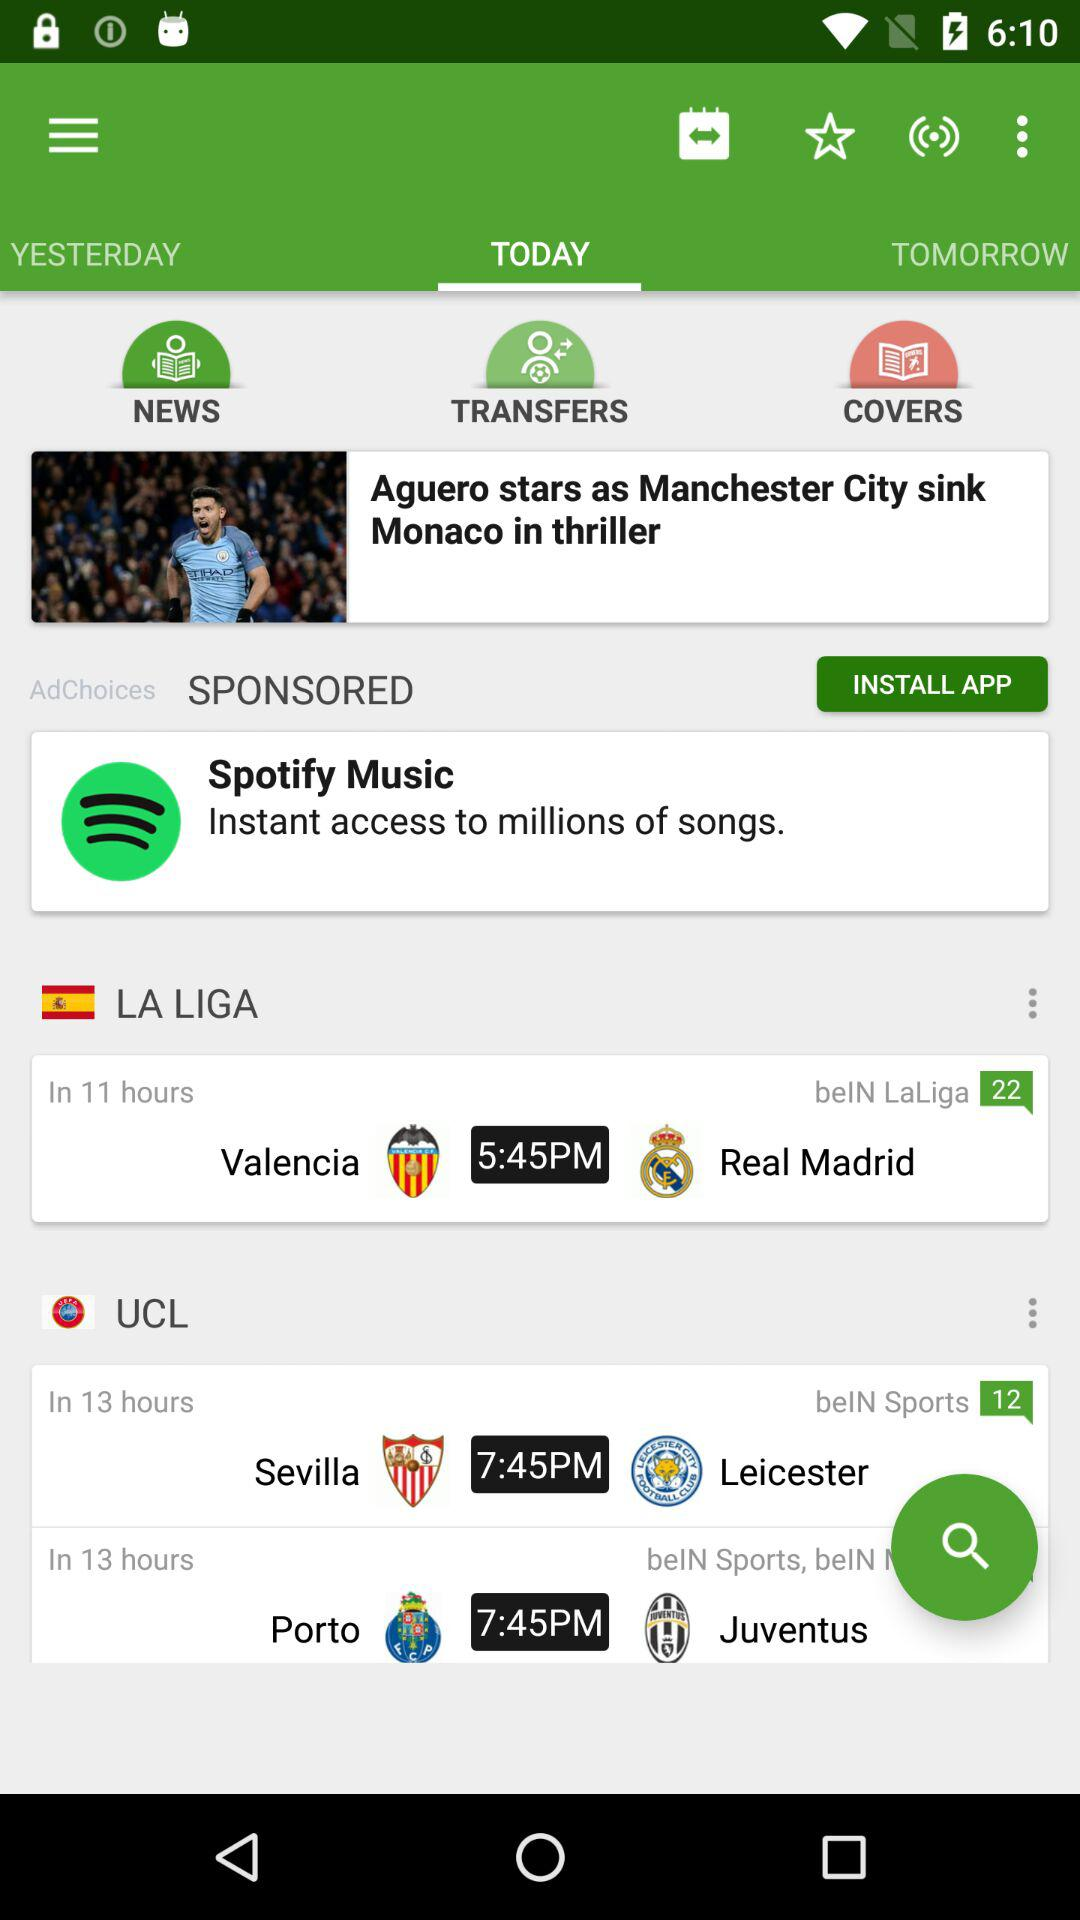How many more hours is the game between Sevilla and Leicester City than the game between Valencia and Real Madrid?
Answer the question using a single word or phrase. 2 